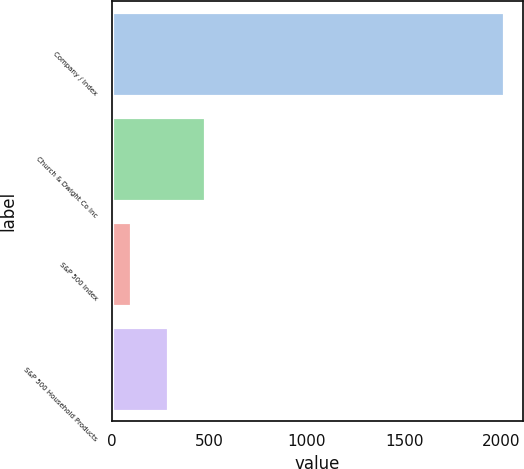Convert chart. <chart><loc_0><loc_0><loc_500><loc_500><bar_chart><fcel>Company / Index<fcel>Church & Dwight Co Inc<fcel>S&P 500 Index<fcel>S&P 500 Household Products<nl><fcel>2011<fcel>481.2<fcel>98.76<fcel>289.98<nl></chart> 